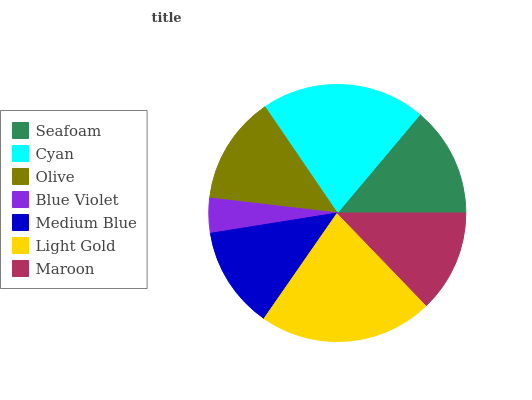Is Blue Violet the minimum?
Answer yes or no. Yes. Is Light Gold the maximum?
Answer yes or no. Yes. Is Cyan the minimum?
Answer yes or no. No. Is Cyan the maximum?
Answer yes or no. No. Is Cyan greater than Seafoam?
Answer yes or no. Yes. Is Seafoam less than Cyan?
Answer yes or no. Yes. Is Seafoam greater than Cyan?
Answer yes or no. No. Is Cyan less than Seafoam?
Answer yes or no. No. Is Olive the high median?
Answer yes or no. Yes. Is Olive the low median?
Answer yes or no. Yes. Is Seafoam the high median?
Answer yes or no. No. Is Medium Blue the low median?
Answer yes or no. No. 